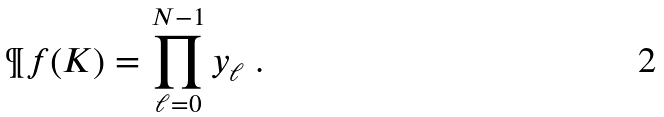Convert formula to latex. <formula><loc_0><loc_0><loc_500><loc_500>\P f ( K ) = \prod _ { \ell = 0 } ^ { N - 1 } y _ { \ell } \ .</formula> 